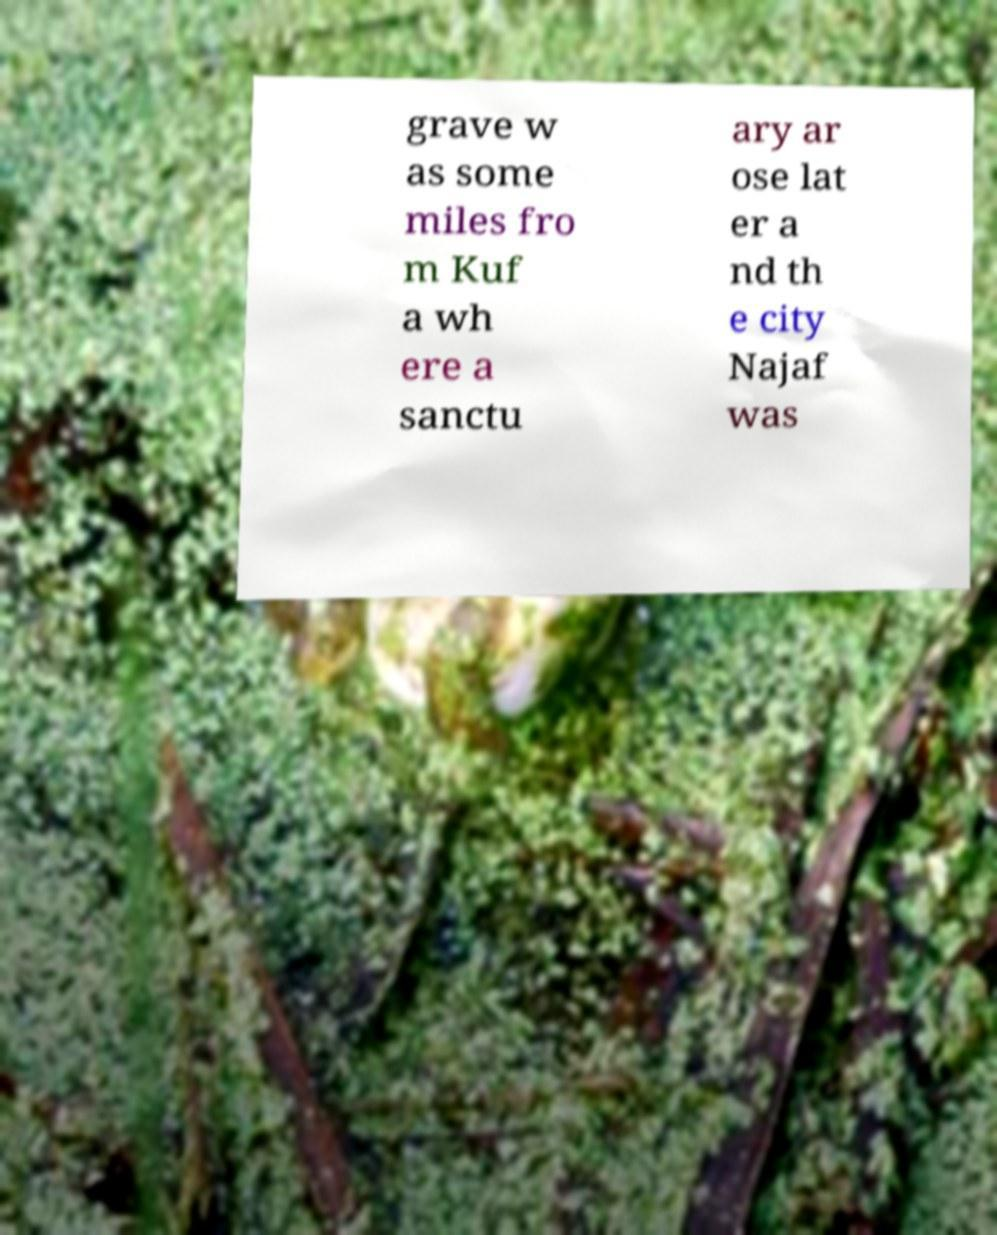Please read and relay the text visible in this image. What does it say? grave w as some miles fro m Kuf a wh ere a sanctu ary ar ose lat er a nd th e city Najaf was 